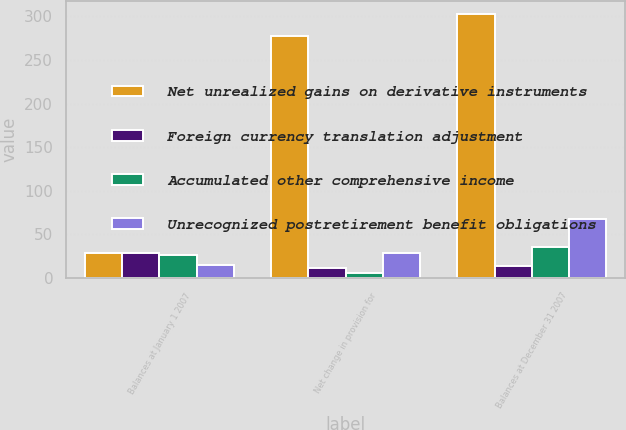Convert chart. <chart><loc_0><loc_0><loc_500><loc_500><stacked_bar_chart><ecel><fcel>Balances at January 1 2007<fcel>Net change in provision for<fcel>Balances at December 31 2007<nl><fcel>Net unrealized gains on derivative instruments<fcel>28.3<fcel>277.7<fcel>302.9<nl><fcel>Foreign currency translation adjustment<fcel>28.3<fcel>11.6<fcel>14.2<nl><fcel>Accumulated other comprehensive income<fcel>26.6<fcel>5.6<fcel>35.9<nl><fcel>Unrecognized postretirement benefit obligations<fcel>14.5<fcel>28.4<fcel>67.2<nl></chart> 